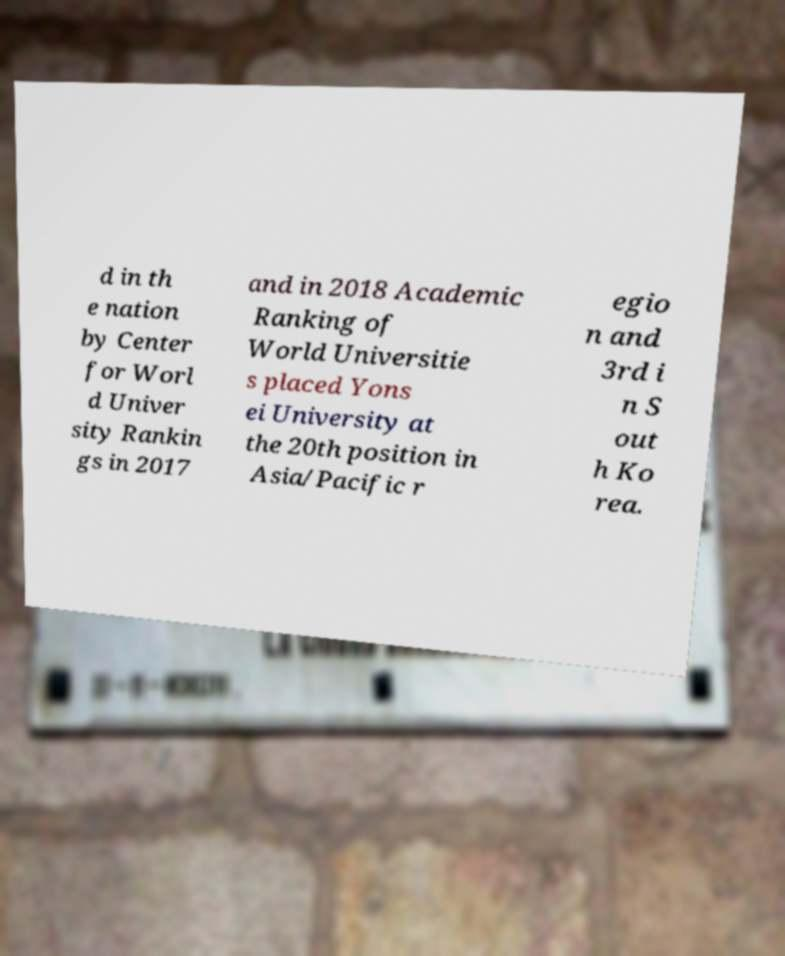I need the written content from this picture converted into text. Can you do that? d in th e nation by Center for Worl d Univer sity Rankin gs in 2017 and in 2018 Academic Ranking of World Universitie s placed Yons ei University at the 20th position in Asia/Pacific r egio n and 3rd i n S out h Ko rea. 